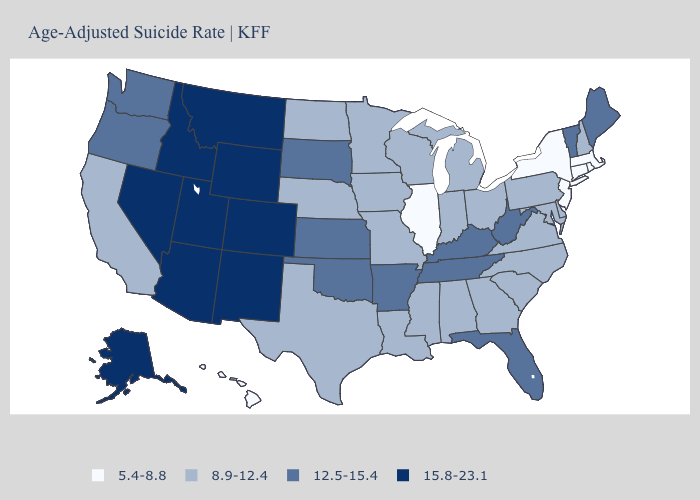What is the value of South Dakota?
Quick response, please. 12.5-15.4. Name the states that have a value in the range 15.8-23.1?
Keep it brief. Alaska, Arizona, Colorado, Idaho, Montana, Nevada, New Mexico, Utah, Wyoming. What is the value of Florida?
Be succinct. 12.5-15.4. Name the states that have a value in the range 5.4-8.8?
Give a very brief answer. Connecticut, Hawaii, Illinois, Massachusetts, New Jersey, New York, Rhode Island. What is the value of Hawaii?
Short answer required. 5.4-8.8. Does the map have missing data?
Concise answer only. No. Does New Jersey have the lowest value in the USA?
Quick response, please. Yes. Among the states that border West Virginia , does Kentucky have the lowest value?
Answer briefly. No. Which states have the lowest value in the South?
Be succinct. Alabama, Delaware, Georgia, Louisiana, Maryland, Mississippi, North Carolina, South Carolina, Texas, Virginia. Among the states that border Georgia , does Florida have the highest value?
Short answer required. Yes. Name the states that have a value in the range 5.4-8.8?
Answer briefly. Connecticut, Hawaii, Illinois, Massachusetts, New Jersey, New York, Rhode Island. What is the lowest value in the USA?
Short answer required. 5.4-8.8. What is the lowest value in the USA?
Short answer required. 5.4-8.8. Is the legend a continuous bar?
Give a very brief answer. No. What is the value of South Dakota?
Concise answer only. 12.5-15.4. 